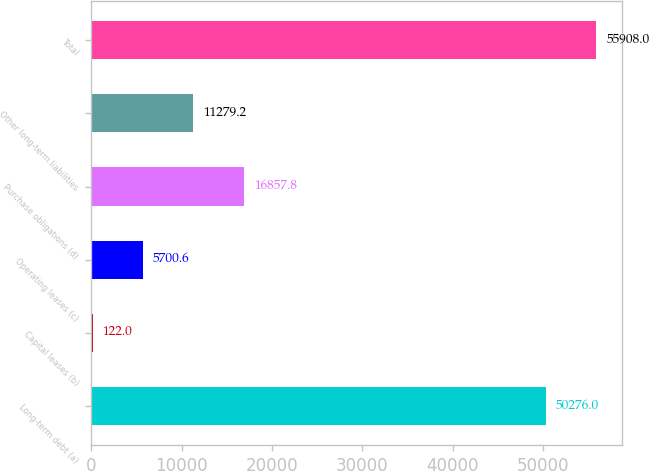<chart> <loc_0><loc_0><loc_500><loc_500><bar_chart><fcel>Long-term debt (a)<fcel>Capital leases (b)<fcel>Operating leases (c)<fcel>Purchase obligations (d)<fcel>Other long-term liabilities<fcel>Total<nl><fcel>50276<fcel>122<fcel>5700.6<fcel>16857.8<fcel>11279.2<fcel>55908<nl></chart> 